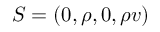<formula> <loc_0><loc_0><loc_500><loc_500>S = ( 0 , \rho , 0 , \rho v )</formula> 